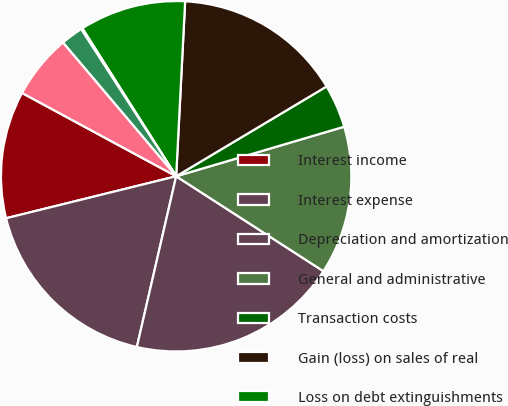Convert chart. <chart><loc_0><loc_0><loc_500><loc_500><pie_chart><fcel>Interest income<fcel>Interest expense<fcel>Depreciation and amortization<fcel>General and administrative<fcel>Transaction costs<fcel>Gain (loss) on sales of real<fcel>Loss on debt extinguishments<fcel>Other income (expense) net<fcel>Income tax benefit (expense)<fcel>Equity income (loss) from<nl><fcel>11.74%<fcel>17.55%<fcel>19.49%<fcel>13.68%<fcel>4.0%<fcel>15.62%<fcel>9.81%<fcel>0.13%<fcel>2.06%<fcel>5.93%<nl></chart> 